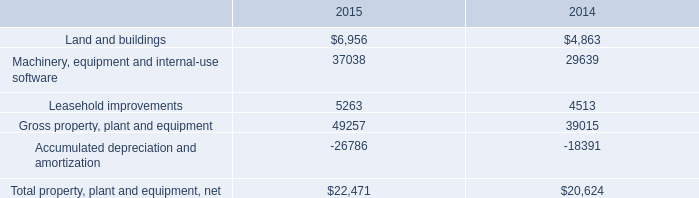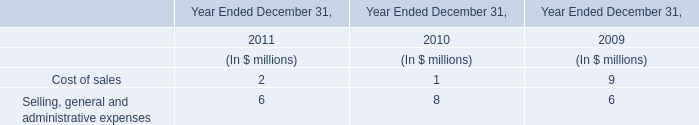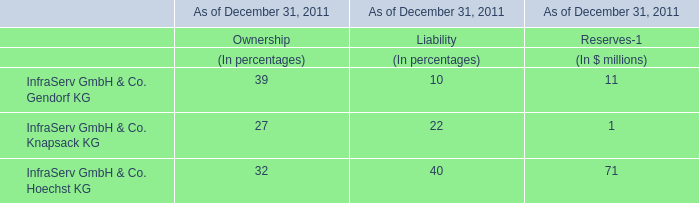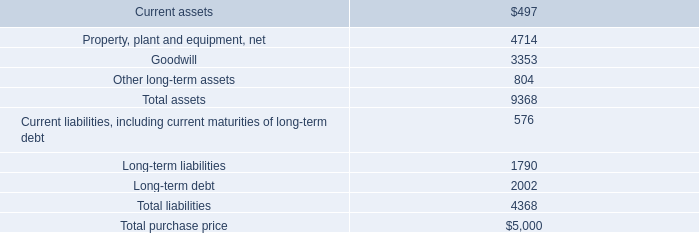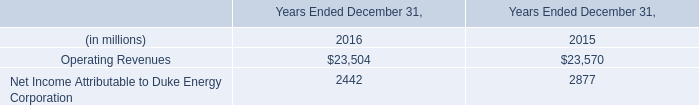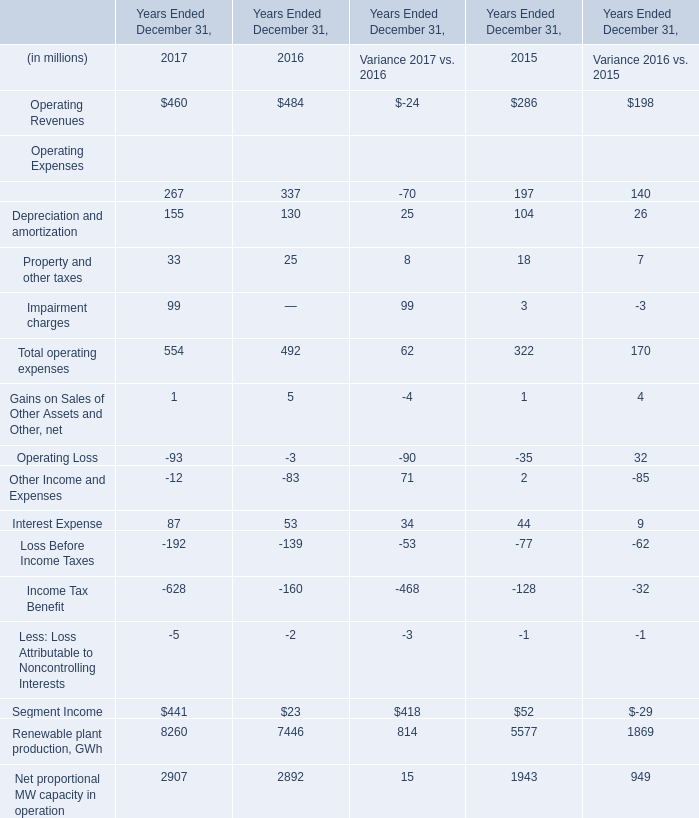as of september 27 , 2014 , what percentage of total trade receivables did the company's two largest customers account for ? 
Computations: (16 + 13)
Answer: 29.0. 